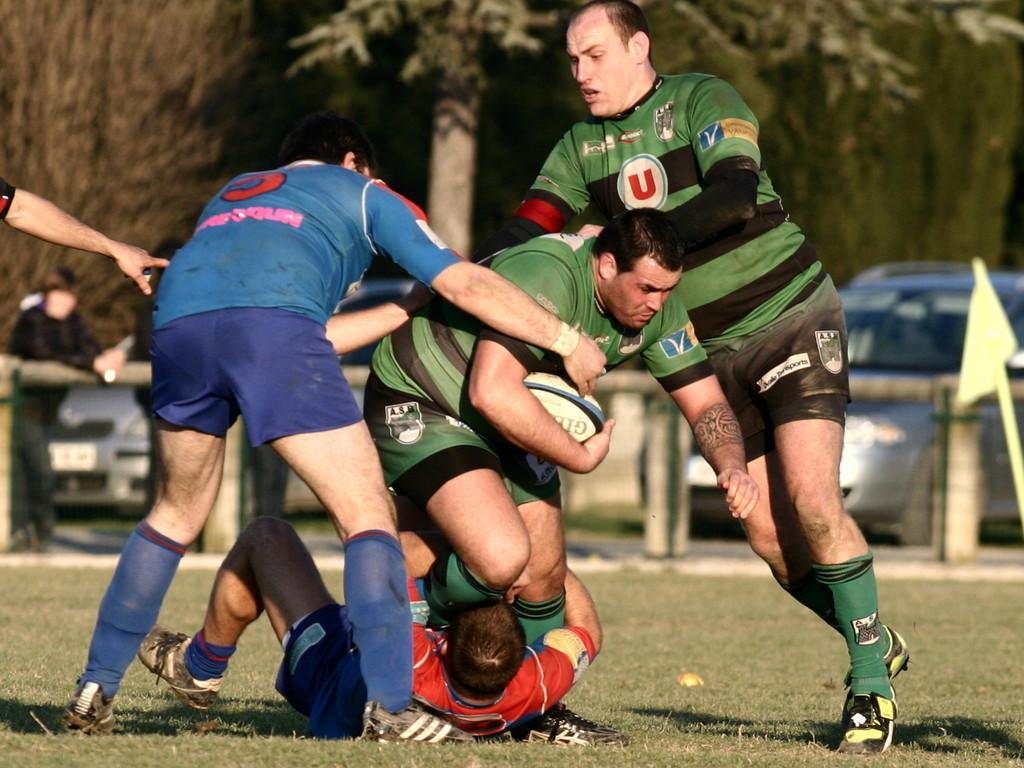Please provide a concise description of this image. In this image In the middle there are four men, they are playing some game. On the right there is a man he wear green t shirt ,trouser,shoes and shocks. In the middle there is a man he wear green t shirt ,trouser,socks and shoes, he is holding a ball. On the left there is a man he wear blue t shirt ,trouser,socks and shoes. At the bottom there is a man he wear red t shirt ,trouser,socks and shoes. In the background there is a man , car,flag and trees. 